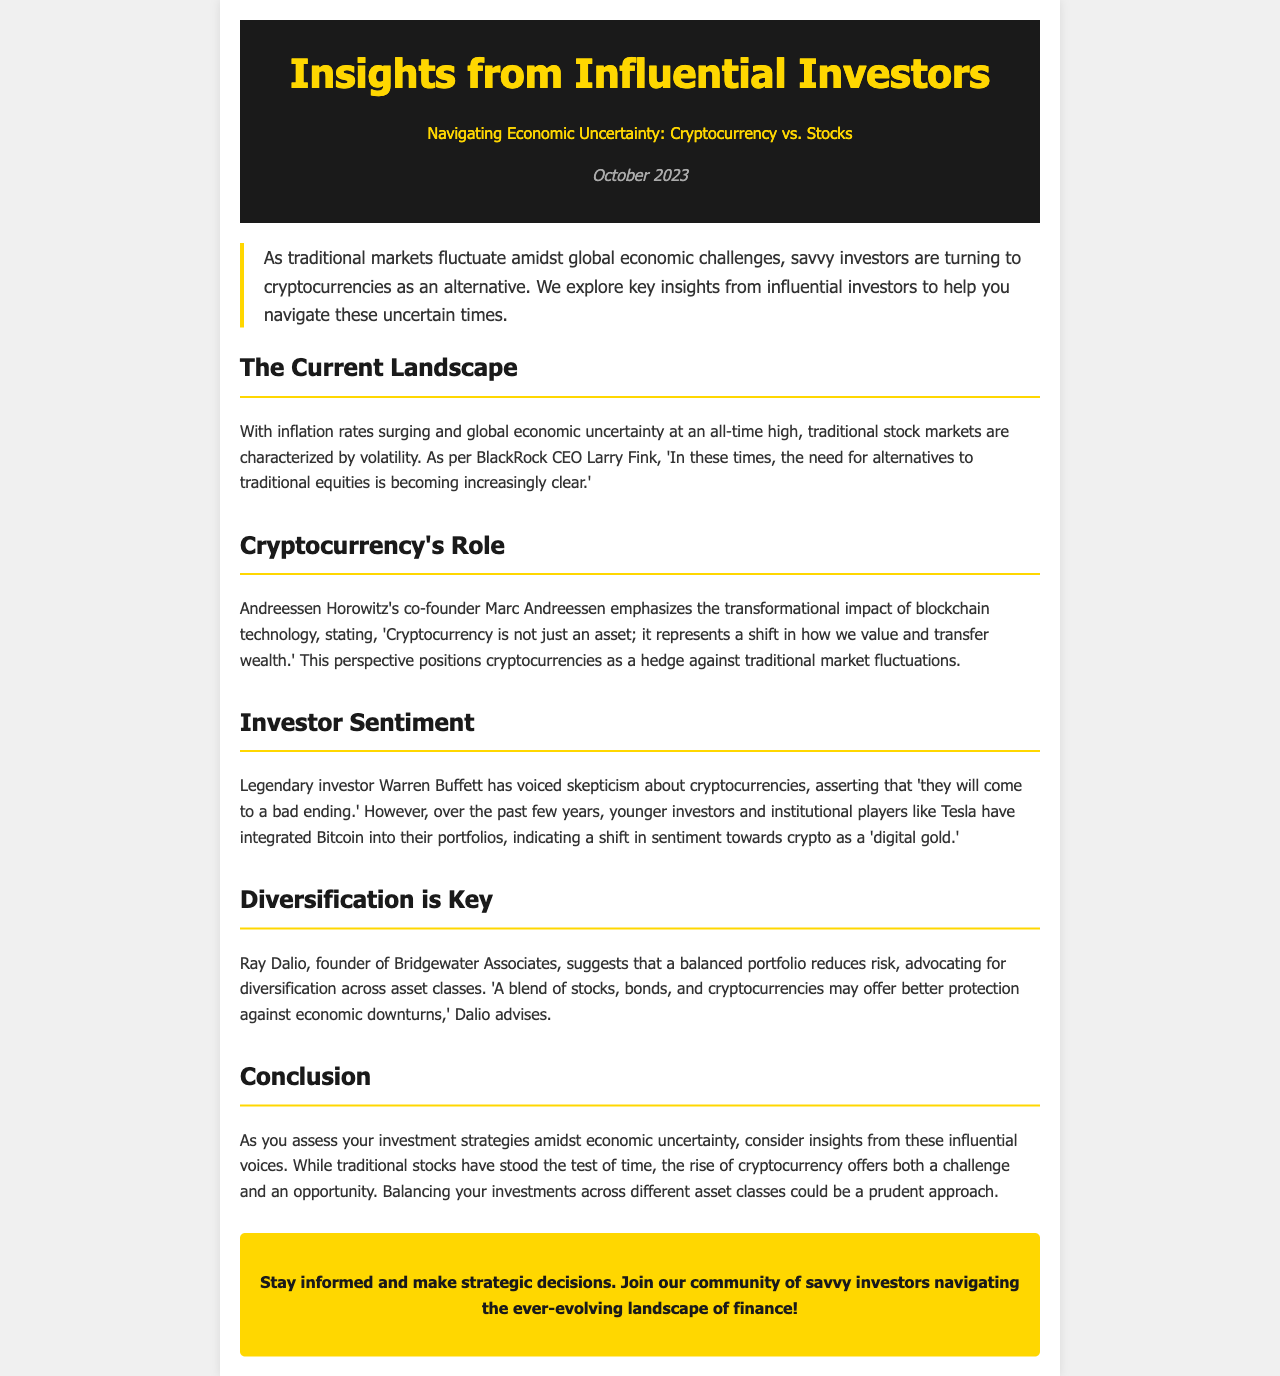What is the publication date of the newsletter? The publication date is explicitly stated in the date section of the document.
Answer: October 2023 Who is the CEO of BlackRock? The document mentions Larry Fink as the CEO of BlackRock.
Answer: Larry Fink What does Marc Andreessen describe cryptocurrency as? Marc Andreessen describes cryptocurrency as a shift in how wealth is valued and transferred.
Answer: A shift in how we value and transfer wealth Which legendary investor has voiced skepticism about cryptocurrencies? The document states that Warren Buffett has expressed skepticism regarding cryptocurrencies.
Answer: Warren Buffett What does Ray Dalio advocate for in investment strategy? Ray Dalio suggests diversification across asset classes to reduce risk in investment strategy.
Answer: Diversification According to the document, what term do younger investors use to refer to Bitcoin? The document states that Bitcoin is referred to as “digital gold” by younger investors.
Answer: Digital gold What is the main topic of the newsletter? The newsletter focuses on navigating the economic uncertainty between cryptocurrency and stocks.
Answer: Navigating Economic Uncertainty: Cryptocurrency vs. Stocks What does the CTA encourage readers to do? The call-to-action (CTA) encourages readers to join the community of savvy investors.
Answer: Join our community of savvy investors 